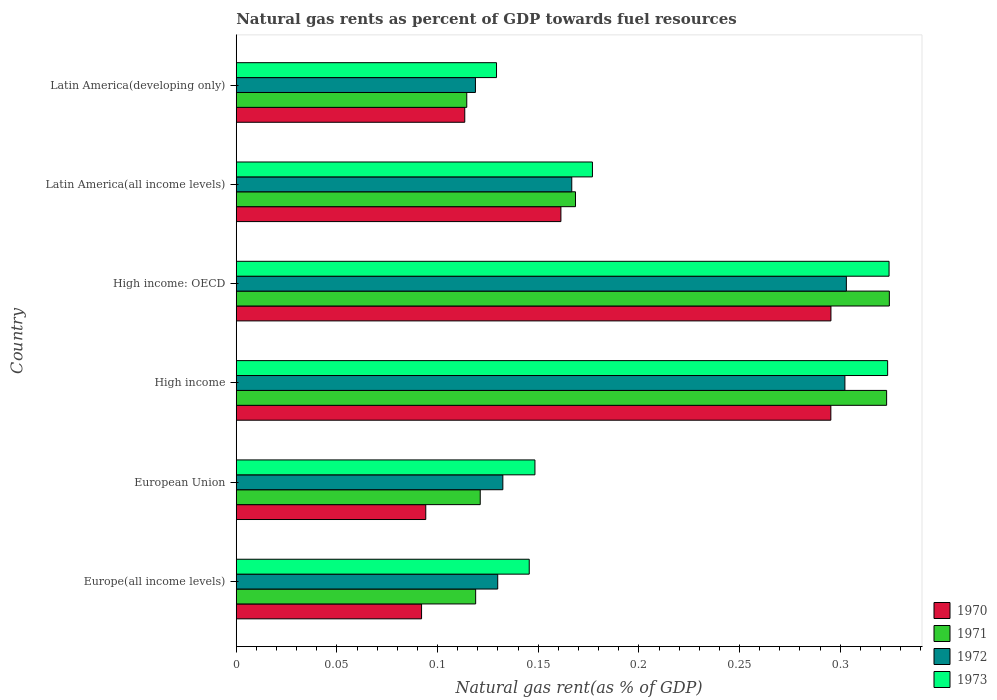How many different coloured bars are there?
Make the answer very short. 4. How many bars are there on the 3rd tick from the top?
Ensure brevity in your answer.  4. What is the label of the 1st group of bars from the top?
Your answer should be compact. Latin America(developing only). What is the natural gas rent in 1972 in Latin America(developing only)?
Keep it short and to the point. 0.12. Across all countries, what is the maximum natural gas rent in 1972?
Give a very brief answer. 0.3. Across all countries, what is the minimum natural gas rent in 1971?
Offer a very short reply. 0.11. In which country was the natural gas rent in 1971 maximum?
Keep it short and to the point. High income: OECD. In which country was the natural gas rent in 1972 minimum?
Provide a short and direct response. Latin America(developing only). What is the total natural gas rent in 1973 in the graph?
Give a very brief answer. 1.25. What is the difference between the natural gas rent in 1972 in Europe(all income levels) and that in High income?
Your response must be concise. -0.17. What is the difference between the natural gas rent in 1971 in Latin America(all income levels) and the natural gas rent in 1972 in European Union?
Offer a terse response. 0.04. What is the average natural gas rent in 1971 per country?
Your response must be concise. 0.2. What is the difference between the natural gas rent in 1972 and natural gas rent in 1971 in European Union?
Ensure brevity in your answer.  0.01. What is the ratio of the natural gas rent in 1973 in High income: OECD to that in Latin America(all income levels)?
Offer a terse response. 1.83. What is the difference between the highest and the second highest natural gas rent in 1972?
Give a very brief answer. 0. What is the difference between the highest and the lowest natural gas rent in 1973?
Offer a very short reply. 0.19. In how many countries, is the natural gas rent in 1970 greater than the average natural gas rent in 1970 taken over all countries?
Provide a succinct answer. 2. Is the sum of the natural gas rent in 1973 in European Union and High income greater than the maximum natural gas rent in 1972 across all countries?
Make the answer very short. Yes. Is it the case that in every country, the sum of the natural gas rent in 1971 and natural gas rent in 1973 is greater than the sum of natural gas rent in 1972 and natural gas rent in 1970?
Give a very brief answer. No. What does the 3rd bar from the bottom in High income: OECD represents?
Your answer should be compact. 1972. Are all the bars in the graph horizontal?
Ensure brevity in your answer.  Yes. How many countries are there in the graph?
Offer a terse response. 6. Are the values on the major ticks of X-axis written in scientific E-notation?
Give a very brief answer. No. Does the graph contain grids?
Your answer should be very brief. No. How many legend labels are there?
Your response must be concise. 4. How are the legend labels stacked?
Your answer should be compact. Vertical. What is the title of the graph?
Your answer should be very brief. Natural gas rents as percent of GDP towards fuel resources. Does "2005" appear as one of the legend labels in the graph?
Make the answer very short. No. What is the label or title of the X-axis?
Keep it short and to the point. Natural gas rent(as % of GDP). What is the Natural gas rent(as % of GDP) of 1970 in Europe(all income levels)?
Your answer should be very brief. 0.09. What is the Natural gas rent(as % of GDP) of 1971 in Europe(all income levels)?
Your response must be concise. 0.12. What is the Natural gas rent(as % of GDP) of 1972 in Europe(all income levels)?
Provide a succinct answer. 0.13. What is the Natural gas rent(as % of GDP) of 1973 in Europe(all income levels)?
Offer a terse response. 0.15. What is the Natural gas rent(as % of GDP) in 1970 in European Union?
Offer a terse response. 0.09. What is the Natural gas rent(as % of GDP) of 1971 in European Union?
Your answer should be very brief. 0.12. What is the Natural gas rent(as % of GDP) of 1972 in European Union?
Offer a terse response. 0.13. What is the Natural gas rent(as % of GDP) of 1973 in European Union?
Keep it short and to the point. 0.15. What is the Natural gas rent(as % of GDP) of 1970 in High income?
Your response must be concise. 0.3. What is the Natural gas rent(as % of GDP) of 1971 in High income?
Provide a short and direct response. 0.32. What is the Natural gas rent(as % of GDP) of 1972 in High income?
Ensure brevity in your answer.  0.3. What is the Natural gas rent(as % of GDP) in 1973 in High income?
Your answer should be compact. 0.32. What is the Natural gas rent(as % of GDP) in 1970 in High income: OECD?
Provide a succinct answer. 0.3. What is the Natural gas rent(as % of GDP) of 1971 in High income: OECD?
Your answer should be very brief. 0.32. What is the Natural gas rent(as % of GDP) in 1972 in High income: OECD?
Provide a succinct answer. 0.3. What is the Natural gas rent(as % of GDP) of 1973 in High income: OECD?
Give a very brief answer. 0.32. What is the Natural gas rent(as % of GDP) of 1970 in Latin America(all income levels)?
Provide a short and direct response. 0.16. What is the Natural gas rent(as % of GDP) in 1971 in Latin America(all income levels)?
Give a very brief answer. 0.17. What is the Natural gas rent(as % of GDP) of 1972 in Latin America(all income levels)?
Your answer should be compact. 0.17. What is the Natural gas rent(as % of GDP) of 1973 in Latin America(all income levels)?
Keep it short and to the point. 0.18. What is the Natural gas rent(as % of GDP) of 1970 in Latin America(developing only)?
Your answer should be compact. 0.11. What is the Natural gas rent(as % of GDP) of 1971 in Latin America(developing only)?
Offer a very short reply. 0.11. What is the Natural gas rent(as % of GDP) of 1972 in Latin America(developing only)?
Your answer should be very brief. 0.12. What is the Natural gas rent(as % of GDP) in 1973 in Latin America(developing only)?
Offer a terse response. 0.13. Across all countries, what is the maximum Natural gas rent(as % of GDP) of 1970?
Your answer should be compact. 0.3. Across all countries, what is the maximum Natural gas rent(as % of GDP) of 1971?
Provide a short and direct response. 0.32. Across all countries, what is the maximum Natural gas rent(as % of GDP) in 1972?
Give a very brief answer. 0.3. Across all countries, what is the maximum Natural gas rent(as % of GDP) of 1973?
Ensure brevity in your answer.  0.32. Across all countries, what is the minimum Natural gas rent(as % of GDP) in 1970?
Give a very brief answer. 0.09. Across all countries, what is the minimum Natural gas rent(as % of GDP) in 1971?
Keep it short and to the point. 0.11. Across all countries, what is the minimum Natural gas rent(as % of GDP) of 1972?
Your answer should be compact. 0.12. Across all countries, what is the minimum Natural gas rent(as % of GDP) of 1973?
Offer a terse response. 0.13. What is the total Natural gas rent(as % of GDP) of 1970 in the graph?
Make the answer very short. 1.05. What is the total Natural gas rent(as % of GDP) of 1971 in the graph?
Provide a short and direct response. 1.17. What is the total Natural gas rent(as % of GDP) of 1972 in the graph?
Provide a succinct answer. 1.15. What is the total Natural gas rent(as % of GDP) of 1973 in the graph?
Your response must be concise. 1.25. What is the difference between the Natural gas rent(as % of GDP) in 1970 in Europe(all income levels) and that in European Union?
Ensure brevity in your answer.  -0. What is the difference between the Natural gas rent(as % of GDP) in 1971 in Europe(all income levels) and that in European Union?
Ensure brevity in your answer.  -0. What is the difference between the Natural gas rent(as % of GDP) of 1972 in Europe(all income levels) and that in European Union?
Make the answer very short. -0. What is the difference between the Natural gas rent(as % of GDP) of 1973 in Europe(all income levels) and that in European Union?
Your answer should be compact. -0. What is the difference between the Natural gas rent(as % of GDP) in 1970 in Europe(all income levels) and that in High income?
Keep it short and to the point. -0.2. What is the difference between the Natural gas rent(as % of GDP) in 1971 in Europe(all income levels) and that in High income?
Offer a terse response. -0.2. What is the difference between the Natural gas rent(as % of GDP) of 1972 in Europe(all income levels) and that in High income?
Make the answer very short. -0.17. What is the difference between the Natural gas rent(as % of GDP) of 1973 in Europe(all income levels) and that in High income?
Make the answer very short. -0.18. What is the difference between the Natural gas rent(as % of GDP) of 1970 in Europe(all income levels) and that in High income: OECD?
Your response must be concise. -0.2. What is the difference between the Natural gas rent(as % of GDP) of 1971 in Europe(all income levels) and that in High income: OECD?
Your response must be concise. -0.21. What is the difference between the Natural gas rent(as % of GDP) of 1972 in Europe(all income levels) and that in High income: OECD?
Provide a succinct answer. -0.17. What is the difference between the Natural gas rent(as % of GDP) of 1973 in Europe(all income levels) and that in High income: OECD?
Give a very brief answer. -0.18. What is the difference between the Natural gas rent(as % of GDP) in 1970 in Europe(all income levels) and that in Latin America(all income levels)?
Offer a very short reply. -0.07. What is the difference between the Natural gas rent(as % of GDP) of 1971 in Europe(all income levels) and that in Latin America(all income levels)?
Provide a succinct answer. -0.05. What is the difference between the Natural gas rent(as % of GDP) of 1972 in Europe(all income levels) and that in Latin America(all income levels)?
Your response must be concise. -0.04. What is the difference between the Natural gas rent(as % of GDP) of 1973 in Europe(all income levels) and that in Latin America(all income levels)?
Your answer should be compact. -0.03. What is the difference between the Natural gas rent(as % of GDP) of 1970 in Europe(all income levels) and that in Latin America(developing only)?
Offer a terse response. -0.02. What is the difference between the Natural gas rent(as % of GDP) of 1971 in Europe(all income levels) and that in Latin America(developing only)?
Give a very brief answer. 0. What is the difference between the Natural gas rent(as % of GDP) of 1972 in Europe(all income levels) and that in Latin America(developing only)?
Provide a short and direct response. 0.01. What is the difference between the Natural gas rent(as % of GDP) of 1973 in Europe(all income levels) and that in Latin America(developing only)?
Provide a succinct answer. 0.02. What is the difference between the Natural gas rent(as % of GDP) in 1970 in European Union and that in High income?
Make the answer very short. -0.2. What is the difference between the Natural gas rent(as % of GDP) of 1971 in European Union and that in High income?
Make the answer very short. -0.2. What is the difference between the Natural gas rent(as % of GDP) of 1972 in European Union and that in High income?
Provide a succinct answer. -0.17. What is the difference between the Natural gas rent(as % of GDP) of 1973 in European Union and that in High income?
Your answer should be compact. -0.18. What is the difference between the Natural gas rent(as % of GDP) in 1970 in European Union and that in High income: OECD?
Make the answer very short. -0.2. What is the difference between the Natural gas rent(as % of GDP) of 1971 in European Union and that in High income: OECD?
Provide a short and direct response. -0.2. What is the difference between the Natural gas rent(as % of GDP) of 1972 in European Union and that in High income: OECD?
Provide a short and direct response. -0.17. What is the difference between the Natural gas rent(as % of GDP) in 1973 in European Union and that in High income: OECD?
Make the answer very short. -0.18. What is the difference between the Natural gas rent(as % of GDP) in 1970 in European Union and that in Latin America(all income levels)?
Offer a very short reply. -0.07. What is the difference between the Natural gas rent(as % of GDP) of 1971 in European Union and that in Latin America(all income levels)?
Give a very brief answer. -0.05. What is the difference between the Natural gas rent(as % of GDP) in 1972 in European Union and that in Latin America(all income levels)?
Offer a terse response. -0.03. What is the difference between the Natural gas rent(as % of GDP) of 1973 in European Union and that in Latin America(all income levels)?
Keep it short and to the point. -0.03. What is the difference between the Natural gas rent(as % of GDP) in 1970 in European Union and that in Latin America(developing only)?
Give a very brief answer. -0.02. What is the difference between the Natural gas rent(as % of GDP) in 1971 in European Union and that in Latin America(developing only)?
Keep it short and to the point. 0.01. What is the difference between the Natural gas rent(as % of GDP) in 1972 in European Union and that in Latin America(developing only)?
Your answer should be compact. 0.01. What is the difference between the Natural gas rent(as % of GDP) in 1973 in European Union and that in Latin America(developing only)?
Your answer should be compact. 0.02. What is the difference between the Natural gas rent(as % of GDP) in 1970 in High income and that in High income: OECD?
Your response must be concise. -0. What is the difference between the Natural gas rent(as % of GDP) in 1971 in High income and that in High income: OECD?
Provide a short and direct response. -0. What is the difference between the Natural gas rent(as % of GDP) of 1972 in High income and that in High income: OECD?
Make the answer very short. -0. What is the difference between the Natural gas rent(as % of GDP) in 1973 in High income and that in High income: OECD?
Give a very brief answer. -0. What is the difference between the Natural gas rent(as % of GDP) of 1970 in High income and that in Latin America(all income levels)?
Provide a succinct answer. 0.13. What is the difference between the Natural gas rent(as % of GDP) in 1971 in High income and that in Latin America(all income levels)?
Provide a succinct answer. 0.15. What is the difference between the Natural gas rent(as % of GDP) in 1972 in High income and that in Latin America(all income levels)?
Provide a succinct answer. 0.14. What is the difference between the Natural gas rent(as % of GDP) of 1973 in High income and that in Latin America(all income levels)?
Give a very brief answer. 0.15. What is the difference between the Natural gas rent(as % of GDP) of 1970 in High income and that in Latin America(developing only)?
Your answer should be very brief. 0.18. What is the difference between the Natural gas rent(as % of GDP) of 1971 in High income and that in Latin America(developing only)?
Keep it short and to the point. 0.21. What is the difference between the Natural gas rent(as % of GDP) of 1972 in High income and that in Latin America(developing only)?
Ensure brevity in your answer.  0.18. What is the difference between the Natural gas rent(as % of GDP) of 1973 in High income and that in Latin America(developing only)?
Make the answer very short. 0.19. What is the difference between the Natural gas rent(as % of GDP) in 1970 in High income: OECD and that in Latin America(all income levels)?
Make the answer very short. 0.13. What is the difference between the Natural gas rent(as % of GDP) of 1971 in High income: OECD and that in Latin America(all income levels)?
Offer a very short reply. 0.16. What is the difference between the Natural gas rent(as % of GDP) of 1972 in High income: OECD and that in Latin America(all income levels)?
Provide a short and direct response. 0.14. What is the difference between the Natural gas rent(as % of GDP) of 1973 in High income: OECD and that in Latin America(all income levels)?
Ensure brevity in your answer.  0.15. What is the difference between the Natural gas rent(as % of GDP) of 1970 in High income: OECD and that in Latin America(developing only)?
Your answer should be compact. 0.18. What is the difference between the Natural gas rent(as % of GDP) in 1971 in High income: OECD and that in Latin America(developing only)?
Your answer should be very brief. 0.21. What is the difference between the Natural gas rent(as % of GDP) in 1972 in High income: OECD and that in Latin America(developing only)?
Make the answer very short. 0.18. What is the difference between the Natural gas rent(as % of GDP) of 1973 in High income: OECD and that in Latin America(developing only)?
Your answer should be compact. 0.2. What is the difference between the Natural gas rent(as % of GDP) in 1970 in Latin America(all income levels) and that in Latin America(developing only)?
Your response must be concise. 0.05. What is the difference between the Natural gas rent(as % of GDP) in 1971 in Latin America(all income levels) and that in Latin America(developing only)?
Keep it short and to the point. 0.05. What is the difference between the Natural gas rent(as % of GDP) of 1972 in Latin America(all income levels) and that in Latin America(developing only)?
Keep it short and to the point. 0.05. What is the difference between the Natural gas rent(as % of GDP) of 1973 in Latin America(all income levels) and that in Latin America(developing only)?
Give a very brief answer. 0.05. What is the difference between the Natural gas rent(as % of GDP) in 1970 in Europe(all income levels) and the Natural gas rent(as % of GDP) in 1971 in European Union?
Your answer should be compact. -0.03. What is the difference between the Natural gas rent(as % of GDP) of 1970 in Europe(all income levels) and the Natural gas rent(as % of GDP) of 1972 in European Union?
Make the answer very short. -0.04. What is the difference between the Natural gas rent(as % of GDP) in 1970 in Europe(all income levels) and the Natural gas rent(as % of GDP) in 1973 in European Union?
Offer a very short reply. -0.06. What is the difference between the Natural gas rent(as % of GDP) of 1971 in Europe(all income levels) and the Natural gas rent(as % of GDP) of 1972 in European Union?
Give a very brief answer. -0.01. What is the difference between the Natural gas rent(as % of GDP) in 1971 in Europe(all income levels) and the Natural gas rent(as % of GDP) in 1973 in European Union?
Your response must be concise. -0.03. What is the difference between the Natural gas rent(as % of GDP) in 1972 in Europe(all income levels) and the Natural gas rent(as % of GDP) in 1973 in European Union?
Offer a terse response. -0.02. What is the difference between the Natural gas rent(as % of GDP) of 1970 in Europe(all income levels) and the Natural gas rent(as % of GDP) of 1971 in High income?
Provide a short and direct response. -0.23. What is the difference between the Natural gas rent(as % of GDP) in 1970 in Europe(all income levels) and the Natural gas rent(as % of GDP) in 1972 in High income?
Offer a terse response. -0.21. What is the difference between the Natural gas rent(as % of GDP) of 1970 in Europe(all income levels) and the Natural gas rent(as % of GDP) of 1973 in High income?
Your answer should be very brief. -0.23. What is the difference between the Natural gas rent(as % of GDP) in 1971 in Europe(all income levels) and the Natural gas rent(as % of GDP) in 1972 in High income?
Provide a short and direct response. -0.18. What is the difference between the Natural gas rent(as % of GDP) in 1971 in Europe(all income levels) and the Natural gas rent(as % of GDP) in 1973 in High income?
Provide a short and direct response. -0.2. What is the difference between the Natural gas rent(as % of GDP) in 1972 in Europe(all income levels) and the Natural gas rent(as % of GDP) in 1973 in High income?
Offer a terse response. -0.19. What is the difference between the Natural gas rent(as % of GDP) of 1970 in Europe(all income levels) and the Natural gas rent(as % of GDP) of 1971 in High income: OECD?
Ensure brevity in your answer.  -0.23. What is the difference between the Natural gas rent(as % of GDP) in 1970 in Europe(all income levels) and the Natural gas rent(as % of GDP) in 1972 in High income: OECD?
Offer a very short reply. -0.21. What is the difference between the Natural gas rent(as % of GDP) in 1970 in Europe(all income levels) and the Natural gas rent(as % of GDP) in 1973 in High income: OECD?
Make the answer very short. -0.23. What is the difference between the Natural gas rent(as % of GDP) of 1971 in Europe(all income levels) and the Natural gas rent(as % of GDP) of 1972 in High income: OECD?
Give a very brief answer. -0.18. What is the difference between the Natural gas rent(as % of GDP) in 1971 in Europe(all income levels) and the Natural gas rent(as % of GDP) in 1973 in High income: OECD?
Provide a short and direct response. -0.21. What is the difference between the Natural gas rent(as % of GDP) in 1972 in Europe(all income levels) and the Natural gas rent(as % of GDP) in 1973 in High income: OECD?
Provide a succinct answer. -0.19. What is the difference between the Natural gas rent(as % of GDP) in 1970 in Europe(all income levels) and the Natural gas rent(as % of GDP) in 1971 in Latin America(all income levels)?
Provide a short and direct response. -0.08. What is the difference between the Natural gas rent(as % of GDP) in 1970 in Europe(all income levels) and the Natural gas rent(as % of GDP) in 1972 in Latin America(all income levels)?
Keep it short and to the point. -0.07. What is the difference between the Natural gas rent(as % of GDP) of 1970 in Europe(all income levels) and the Natural gas rent(as % of GDP) of 1973 in Latin America(all income levels)?
Offer a very short reply. -0.08. What is the difference between the Natural gas rent(as % of GDP) of 1971 in Europe(all income levels) and the Natural gas rent(as % of GDP) of 1972 in Latin America(all income levels)?
Keep it short and to the point. -0.05. What is the difference between the Natural gas rent(as % of GDP) of 1971 in Europe(all income levels) and the Natural gas rent(as % of GDP) of 1973 in Latin America(all income levels)?
Offer a very short reply. -0.06. What is the difference between the Natural gas rent(as % of GDP) of 1972 in Europe(all income levels) and the Natural gas rent(as % of GDP) of 1973 in Latin America(all income levels)?
Give a very brief answer. -0.05. What is the difference between the Natural gas rent(as % of GDP) in 1970 in Europe(all income levels) and the Natural gas rent(as % of GDP) in 1971 in Latin America(developing only)?
Your answer should be very brief. -0.02. What is the difference between the Natural gas rent(as % of GDP) of 1970 in Europe(all income levels) and the Natural gas rent(as % of GDP) of 1972 in Latin America(developing only)?
Give a very brief answer. -0.03. What is the difference between the Natural gas rent(as % of GDP) of 1970 in Europe(all income levels) and the Natural gas rent(as % of GDP) of 1973 in Latin America(developing only)?
Your response must be concise. -0.04. What is the difference between the Natural gas rent(as % of GDP) of 1971 in Europe(all income levels) and the Natural gas rent(as % of GDP) of 1973 in Latin America(developing only)?
Offer a very short reply. -0.01. What is the difference between the Natural gas rent(as % of GDP) of 1972 in Europe(all income levels) and the Natural gas rent(as % of GDP) of 1973 in Latin America(developing only)?
Give a very brief answer. 0. What is the difference between the Natural gas rent(as % of GDP) in 1970 in European Union and the Natural gas rent(as % of GDP) in 1971 in High income?
Give a very brief answer. -0.23. What is the difference between the Natural gas rent(as % of GDP) of 1970 in European Union and the Natural gas rent(as % of GDP) of 1972 in High income?
Your answer should be very brief. -0.21. What is the difference between the Natural gas rent(as % of GDP) of 1970 in European Union and the Natural gas rent(as % of GDP) of 1973 in High income?
Make the answer very short. -0.23. What is the difference between the Natural gas rent(as % of GDP) in 1971 in European Union and the Natural gas rent(as % of GDP) in 1972 in High income?
Provide a succinct answer. -0.18. What is the difference between the Natural gas rent(as % of GDP) of 1971 in European Union and the Natural gas rent(as % of GDP) of 1973 in High income?
Your response must be concise. -0.2. What is the difference between the Natural gas rent(as % of GDP) in 1972 in European Union and the Natural gas rent(as % of GDP) in 1973 in High income?
Ensure brevity in your answer.  -0.19. What is the difference between the Natural gas rent(as % of GDP) of 1970 in European Union and the Natural gas rent(as % of GDP) of 1971 in High income: OECD?
Your answer should be very brief. -0.23. What is the difference between the Natural gas rent(as % of GDP) in 1970 in European Union and the Natural gas rent(as % of GDP) in 1972 in High income: OECD?
Ensure brevity in your answer.  -0.21. What is the difference between the Natural gas rent(as % of GDP) of 1970 in European Union and the Natural gas rent(as % of GDP) of 1973 in High income: OECD?
Provide a short and direct response. -0.23. What is the difference between the Natural gas rent(as % of GDP) of 1971 in European Union and the Natural gas rent(as % of GDP) of 1972 in High income: OECD?
Provide a short and direct response. -0.18. What is the difference between the Natural gas rent(as % of GDP) of 1971 in European Union and the Natural gas rent(as % of GDP) of 1973 in High income: OECD?
Provide a short and direct response. -0.2. What is the difference between the Natural gas rent(as % of GDP) in 1972 in European Union and the Natural gas rent(as % of GDP) in 1973 in High income: OECD?
Give a very brief answer. -0.19. What is the difference between the Natural gas rent(as % of GDP) in 1970 in European Union and the Natural gas rent(as % of GDP) in 1971 in Latin America(all income levels)?
Offer a very short reply. -0.07. What is the difference between the Natural gas rent(as % of GDP) of 1970 in European Union and the Natural gas rent(as % of GDP) of 1972 in Latin America(all income levels)?
Offer a terse response. -0.07. What is the difference between the Natural gas rent(as % of GDP) in 1970 in European Union and the Natural gas rent(as % of GDP) in 1973 in Latin America(all income levels)?
Your answer should be compact. -0.08. What is the difference between the Natural gas rent(as % of GDP) of 1971 in European Union and the Natural gas rent(as % of GDP) of 1972 in Latin America(all income levels)?
Your answer should be compact. -0.05. What is the difference between the Natural gas rent(as % of GDP) of 1971 in European Union and the Natural gas rent(as % of GDP) of 1973 in Latin America(all income levels)?
Your answer should be very brief. -0.06. What is the difference between the Natural gas rent(as % of GDP) in 1972 in European Union and the Natural gas rent(as % of GDP) in 1973 in Latin America(all income levels)?
Give a very brief answer. -0.04. What is the difference between the Natural gas rent(as % of GDP) in 1970 in European Union and the Natural gas rent(as % of GDP) in 1971 in Latin America(developing only)?
Offer a terse response. -0.02. What is the difference between the Natural gas rent(as % of GDP) of 1970 in European Union and the Natural gas rent(as % of GDP) of 1972 in Latin America(developing only)?
Your answer should be compact. -0.02. What is the difference between the Natural gas rent(as % of GDP) in 1970 in European Union and the Natural gas rent(as % of GDP) in 1973 in Latin America(developing only)?
Keep it short and to the point. -0.04. What is the difference between the Natural gas rent(as % of GDP) in 1971 in European Union and the Natural gas rent(as % of GDP) in 1972 in Latin America(developing only)?
Provide a short and direct response. 0. What is the difference between the Natural gas rent(as % of GDP) in 1971 in European Union and the Natural gas rent(as % of GDP) in 1973 in Latin America(developing only)?
Make the answer very short. -0.01. What is the difference between the Natural gas rent(as % of GDP) in 1972 in European Union and the Natural gas rent(as % of GDP) in 1973 in Latin America(developing only)?
Your response must be concise. 0. What is the difference between the Natural gas rent(as % of GDP) of 1970 in High income and the Natural gas rent(as % of GDP) of 1971 in High income: OECD?
Keep it short and to the point. -0.03. What is the difference between the Natural gas rent(as % of GDP) of 1970 in High income and the Natural gas rent(as % of GDP) of 1972 in High income: OECD?
Ensure brevity in your answer.  -0.01. What is the difference between the Natural gas rent(as % of GDP) of 1970 in High income and the Natural gas rent(as % of GDP) of 1973 in High income: OECD?
Offer a terse response. -0.03. What is the difference between the Natural gas rent(as % of GDP) of 1971 in High income and the Natural gas rent(as % of GDP) of 1973 in High income: OECD?
Your answer should be compact. -0. What is the difference between the Natural gas rent(as % of GDP) in 1972 in High income and the Natural gas rent(as % of GDP) in 1973 in High income: OECD?
Your answer should be very brief. -0.02. What is the difference between the Natural gas rent(as % of GDP) of 1970 in High income and the Natural gas rent(as % of GDP) of 1971 in Latin America(all income levels)?
Offer a very short reply. 0.13. What is the difference between the Natural gas rent(as % of GDP) in 1970 in High income and the Natural gas rent(as % of GDP) in 1972 in Latin America(all income levels)?
Provide a short and direct response. 0.13. What is the difference between the Natural gas rent(as % of GDP) of 1970 in High income and the Natural gas rent(as % of GDP) of 1973 in Latin America(all income levels)?
Your answer should be very brief. 0.12. What is the difference between the Natural gas rent(as % of GDP) in 1971 in High income and the Natural gas rent(as % of GDP) in 1972 in Latin America(all income levels)?
Your answer should be very brief. 0.16. What is the difference between the Natural gas rent(as % of GDP) of 1971 in High income and the Natural gas rent(as % of GDP) of 1973 in Latin America(all income levels)?
Keep it short and to the point. 0.15. What is the difference between the Natural gas rent(as % of GDP) in 1972 in High income and the Natural gas rent(as % of GDP) in 1973 in Latin America(all income levels)?
Provide a short and direct response. 0.13. What is the difference between the Natural gas rent(as % of GDP) in 1970 in High income and the Natural gas rent(as % of GDP) in 1971 in Latin America(developing only)?
Give a very brief answer. 0.18. What is the difference between the Natural gas rent(as % of GDP) of 1970 in High income and the Natural gas rent(as % of GDP) of 1972 in Latin America(developing only)?
Your answer should be compact. 0.18. What is the difference between the Natural gas rent(as % of GDP) of 1970 in High income and the Natural gas rent(as % of GDP) of 1973 in Latin America(developing only)?
Your answer should be very brief. 0.17. What is the difference between the Natural gas rent(as % of GDP) in 1971 in High income and the Natural gas rent(as % of GDP) in 1972 in Latin America(developing only)?
Keep it short and to the point. 0.2. What is the difference between the Natural gas rent(as % of GDP) of 1971 in High income and the Natural gas rent(as % of GDP) of 1973 in Latin America(developing only)?
Offer a terse response. 0.19. What is the difference between the Natural gas rent(as % of GDP) of 1972 in High income and the Natural gas rent(as % of GDP) of 1973 in Latin America(developing only)?
Offer a terse response. 0.17. What is the difference between the Natural gas rent(as % of GDP) in 1970 in High income: OECD and the Natural gas rent(as % of GDP) in 1971 in Latin America(all income levels)?
Your answer should be compact. 0.13. What is the difference between the Natural gas rent(as % of GDP) of 1970 in High income: OECD and the Natural gas rent(as % of GDP) of 1972 in Latin America(all income levels)?
Provide a short and direct response. 0.13. What is the difference between the Natural gas rent(as % of GDP) of 1970 in High income: OECD and the Natural gas rent(as % of GDP) of 1973 in Latin America(all income levels)?
Offer a very short reply. 0.12. What is the difference between the Natural gas rent(as % of GDP) of 1971 in High income: OECD and the Natural gas rent(as % of GDP) of 1972 in Latin America(all income levels)?
Your answer should be very brief. 0.16. What is the difference between the Natural gas rent(as % of GDP) in 1971 in High income: OECD and the Natural gas rent(as % of GDP) in 1973 in Latin America(all income levels)?
Provide a succinct answer. 0.15. What is the difference between the Natural gas rent(as % of GDP) of 1972 in High income: OECD and the Natural gas rent(as % of GDP) of 1973 in Latin America(all income levels)?
Provide a succinct answer. 0.13. What is the difference between the Natural gas rent(as % of GDP) of 1970 in High income: OECD and the Natural gas rent(as % of GDP) of 1971 in Latin America(developing only)?
Keep it short and to the point. 0.18. What is the difference between the Natural gas rent(as % of GDP) in 1970 in High income: OECD and the Natural gas rent(as % of GDP) in 1972 in Latin America(developing only)?
Provide a short and direct response. 0.18. What is the difference between the Natural gas rent(as % of GDP) in 1970 in High income: OECD and the Natural gas rent(as % of GDP) in 1973 in Latin America(developing only)?
Provide a succinct answer. 0.17. What is the difference between the Natural gas rent(as % of GDP) of 1971 in High income: OECD and the Natural gas rent(as % of GDP) of 1972 in Latin America(developing only)?
Give a very brief answer. 0.21. What is the difference between the Natural gas rent(as % of GDP) of 1971 in High income: OECD and the Natural gas rent(as % of GDP) of 1973 in Latin America(developing only)?
Make the answer very short. 0.2. What is the difference between the Natural gas rent(as % of GDP) of 1972 in High income: OECD and the Natural gas rent(as % of GDP) of 1973 in Latin America(developing only)?
Your response must be concise. 0.17. What is the difference between the Natural gas rent(as % of GDP) of 1970 in Latin America(all income levels) and the Natural gas rent(as % of GDP) of 1971 in Latin America(developing only)?
Provide a short and direct response. 0.05. What is the difference between the Natural gas rent(as % of GDP) of 1970 in Latin America(all income levels) and the Natural gas rent(as % of GDP) of 1972 in Latin America(developing only)?
Offer a very short reply. 0.04. What is the difference between the Natural gas rent(as % of GDP) of 1970 in Latin America(all income levels) and the Natural gas rent(as % of GDP) of 1973 in Latin America(developing only)?
Offer a terse response. 0.03. What is the difference between the Natural gas rent(as % of GDP) of 1971 in Latin America(all income levels) and the Natural gas rent(as % of GDP) of 1972 in Latin America(developing only)?
Provide a succinct answer. 0.05. What is the difference between the Natural gas rent(as % of GDP) in 1971 in Latin America(all income levels) and the Natural gas rent(as % of GDP) in 1973 in Latin America(developing only)?
Ensure brevity in your answer.  0.04. What is the difference between the Natural gas rent(as % of GDP) of 1972 in Latin America(all income levels) and the Natural gas rent(as % of GDP) of 1973 in Latin America(developing only)?
Your answer should be very brief. 0.04. What is the average Natural gas rent(as % of GDP) of 1970 per country?
Ensure brevity in your answer.  0.18. What is the average Natural gas rent(as % of GDP) in 1971 per country?
Provide a short and direct response. 0.2. What is the average Natural gas rent(as % of GDP) in 1972 per country?
Your answer should be very brief. 0.19. What is the average Natural gas rent(as % of GDP) in 1973 per country?
Provide a succinct answer. 0.21. What is the difference between the Natural gas rent(as % of GDP) in 1970 and Natural gas rent(as % of GDP) in 1971 in Europe(all income levels)?
Your answer should be very brief. -0.03. What is the difference between the Natural gas rent(as % of GDP) of 1970 and Natural gas rent(as % of GDP) of 1972 in Europe(all income levels)?
Make the answer very short. -0.04. What is the difference between the Natural gas rent(as % of GDP) of 1970 and Natural gas rent(as % of GDP) of 1973 in Europe(all income levels)?
Provide a short and direct response. -0.05. What is the difference between the Natural gas rent(as % of GDP) in 1971 and Natural gas rent(as % of GDP) in 1972 in Europe(all income levels)?
Your answer should be very brief. -0.01. What is the difference between the Natural gas rent(as % of GDP) in 1971 and Natural gas rent(as % of GDP) in 1973 in Europe(all income levels)?
Offer a very short reply. -0.03. What is the difference between the Natural gas rent(as % of GDP) of 1972 and Natural gas rent(as % of GDP) of 1973 in Europe(all income levels)?
Your answer should be very brief. -0.02. What is the difference between the Natural gas rent(as % of GDP) of 1970 and Natural gas rent(as % of GDP) of 1971 in European Union?
Keep it short and to the point. -0.03. What is the difference between the Natural gas rent(as % of GDP) in 1970 and Natural gas rent(as % of GDP) in 1972 in European Union?
Provide a succinct answer. -0.04. What is the difference between the Natural gas rent(as % of GDP) of 1970 and Natural gas rent(as % of GDP) of 1973 in European Union?
Your answer should be compact. -0.05. What is the difference between the Natural gas rent(as % of GDP) of 1971 and Natural gas rent(as % of GDP) of 1972 in European Union?
Give a very brief answer. -0.01. What is the difference between the Natural gas rent(as % of GDP) of 1971 and Natural gas rent(as % of GDP) of 1973 in European Union?
Keep it short and to the point. -0.03. What is the difference between the Natural gas rent(as % of GDP) of 1972 and Natural gas rent(as % of GDP) of 1973 in European Union?
Offer a very short reply. -0.02. What is the difference between the Natural gas rent(as % of GDP) of 1970 and Natural gas rent(as % of GDP) of 1971 in High income?
Keep it short and to the point. -0.03. What is the difference between the Natural gas rent(as % of GDP) in 1970 and Natural gas rent(as % of GDP) in 1972 in High income?
Offer a terse response. -0.01. What is the difference between the Natural gas rent(as % of GDP) of 1970 and Natural gas rent(as % of GDP) of 1973 in High income?
Your answer should be very brief. -0.03. What is the difference between the Natural gas rent(as % of GDP) in 1971 and Natural gas rent(as % of GDP) in 1972 in High income?
Make the answer very short. 0.02. What is the difference between the Natural gas rent(as % of GDP) of 1971 and Natural gas rent(as % of GDP) of 1973 in High income?
Your answer should be very brief. -0. What is the difference between the Natural gas rent(as % of GDP) of 1972 and Natural gas rent(as % of GDP) of 1973 in High income?
Your answer should be very brief. -0.02. What is the difference between the Natural gas rent(as % of GDP) in 1970 and Natural gas rent(as % of GDP) in 1971 in High income: OECD?
Provide a succinct answer. -0.03. What is the difference between the Natural gas rent(as % of GDP) of 1970 and Natural gas rent(as % of GDP) of 1972 in High income: OECD?
Your answer should be very brief. -0.01. What is the difference between the Natural gas rent(as % of GDP) of 1970 and Natural gas rent(as % of GDP) of 1973 in High income: OECD?
Your answer should be very brief. -0.03. What is the difference between the Natural gas rent(as % of GDP) of 1971 and Natural gas rent(as % of GDP) of 1972 in High income: OECD?
Make the answer very short. 0.02. What is the difference between the Natural gas rent(as % of GDP) in 1971 and Natural gas rent(as % of GDP) in 1973 in High income: OECD?
Your answer should be very brief. 0. What is the difference between the Natural gas rent(as % of GDP) of 1972 and Natural gas rent(as % of GDP) of 1973 in High income: OECD?
Provide a short and direct response. -0.02. What is the difference between the Natural gas rent(as % of GDP) of 1970 and Natural gas rent(as % of GDP) of 1971 in Latin America(all income levels)?
Your answer should be compact. -0.01. What is the difference between the Natural gas rent(as % of GDP) in 1970 and Natural gas rent(as % of GDP) in 1972 in Latin America(all income levels)?
Offer a terse response. -0.01. What is the difference between the Natural gas rent(as % of GDP) in 1970 and Natural gas rent(as % of GDP) in 1973 in Latin America(all income levels)?
Keep it short and to the point. -0.02. What is the difference between the Natural gas rent(as % of GDP) of 1971 and Natural gas rent(as % of GDP) of 1972 in Latin America(all income levels)?
Your answer should be compact. 0. What is the difference between the Natural gas rent(as % of GDP) of 1971 and Natural gas rent(as % of GDP) of 1973 in Latin America(all income levels)?
Provide a succinct answer. -0.01. What is the difference between the Natural gas rent(as % of GDP) of 1972 and Natural gas rent(as % of GDP) of 1973 in Latin America(all income levels)?
Give a very brief answer. -0.01. What is the difference between the Natural gas rent(as % of GDP) in 1970 and Natural gas rent(as % of GDP) in 1971 in Latin America(developing only)?
Offer a very short reply. -0. What is the difference between the Natural gas rent(as % of GDP) in 1970 and Natural gas rent(as % of GDP) in 1972 in Latin America(developing only)?
Ensure brevity in your answer.  -0.01. What is the difference between the Natural gas rent(as % of GDP) of 1970 and Natural gas rent(as % of GDP) of 1973 in Latin America(developing only)?
Offer a terse response. -0.02. What is the difference between the Natural gas rent(as % of GDP) of 1971 and Natural gas rent(as % of GDP) of 1972 in Latin America(developing only)?
Offer a very short reply. -0. What is the difference between the Natural gas rent(as % of GDP) in 1971 and Natural gas rent(as % of GDP) in 1973 in Latin America(developing only)?
Ensure brevity in your answer.  -0.01. What is the difference between the Natural gas rent(as % of GDP) of 1972 and Natural gas rent(as % of GDP) of 1973 in Latin America(developing only)?
Offer a terse response. -0.01. What is the ratio of the Natural gas rent(as % of GDP) of 1970 in Europe(all income levels) to that in European Union?
Your answer should be compact. 0.98. What is the ratio of the Natural gas rent(as % of GDP) in 1971 in Europe(all income levels) to that in European Union?
Provide a succinct answer. 0.98. What is the ratio of the Natural gas rent(as % of GDP) in 1972 in Europe(all income levels) to that in European Union?
Ensure brevity in your answer.  0.98. What is the ratio of the Natural gas rent(as % of GDP) in 1973 in Europe(all income levels) to that in European Union?
Offer a very short reply. 0.98. What is the ratio of the Natural gas rent(as % of GDP) in 1970 in Europe(all income levels) to that in High income?
Your answer should be compact. 0.31. What is the ratio of the Natural gas rent(as % of GDP) of 1971 in Europe(all income levels) to that in High income?
Make the answer very short. 0.37. What is the ratio of the Natural gas rent(as % of GDP) in 1972 in Europe(all income levels) to that in High income?
Offer a very short reply. 0.43. What is the ratio of the Natural gas rent(as % of GDP) of 1973 in Europe(all income levels) to that in High income?
Give a very brief answer. 0.45. What is the ratio of the Natural gas rent(as % of GDP) in 1970 in Europe(all income levels) to that in High income: OECD?
Provide a succinct answer. 0.31. What is the ratio of the Natural gas rent(as % of GDP) in 1971 in Europe(all income levels) to that in High income: OECD?
Your answer should be very brief. 0.37. What is the ratio of the Natural gas rent(as % of GDP) of 1972 in Europe(all income levels) to that in High income: OECD?
Provide a succinct answer. 0.43. What is the ratio of the Natural gas rent(as % of GDP) in 1973 in Europe(all income levels) to that in High income: OECD?
Offer a very short reply. 0.45. What is the ratio of the Natural gas rent(as % of GDP) of 1970 in Europe(all income levels) to that in Latin America(all income levels)?
Ensure brevity in your answer.  0.57. What is the ratio of the Natural gas rent(as % of GDP) in 1971 in Europe(all income levels) to that in Latin America(all income levels)?
Your answer should be compact. 0.71. What is the ratio of the Natural gas rent(as % of GDP) in 1972 in Europe(all income levels) to that in Latin America(all income levels)?
Your answer should be very brief. 0.78. What is the ratio of the Natural gas rent(as % of GDP) in 1973 in Europe(all income levels) to that in Latin America(all income levels)?
Provide a short and direct response. 0.82. What is the ratio of the Natural gas rent(as % of GDP) of 1970 in Europe(all income levels) to that in Latin America(developing only)?
Offer a terse response. 0.81. What is the ratio of the Natural gas rent(as % of GDP) in 1971 in Europe(all income levels) to that in Latin America(developing only)?
Your answer should be very brief. 1.04. What is the ratio of the Natural gas rent(as % of GDP) in 1972 in Europe(all income levels) to that in Latin America(developing only)?
Offer a terse response. 1.09. What is the ratio of the Natural gas rent(as % of GDP) of 1973 in Europe(all income levels) to that in Latin America(developing only)?
Keep it short and to the point. 1.13. What is the ratio of the Natural gas rent(as % of GDP) in 1970 in European Union to that in High income?
Provide a succinct answer. 0.32. What is the ratio of the Natural gas rent(as % of GDP) in 1971 in European Union to that in High income?
Ensure brevity in your answer.  0.38. What is the ratio of the Natural gas rent(as % of GDP) in 1972 in European Union to that in High income?
Keep it short and to the point. 0.44. What is the ratio of the Natural gas rent(as % of GDP) in 1973 in European Union to that in High income?
Offer a terse response. 0.46. What is the ratio of the Natural gas rent(as % of GDP) in 1970 in European Union to that in High income: OECD?
Your response must be concise. 0.32. What is the ratio of the Natural gas rent(as % of GDP) in 1971 in European Union to that in High income: OECD?
Provide a short and direct response. 0.37. What is the ratio of the Natural gas rent(as % of GDP) in 1972 in European Union to that in High income: OECD?
Offer a terse response. 0.44. What is the ratio of the Natural gas rent(as % of GDP) in 1973 in European Union to that in High income: OECD?
Make the answer very short. 0.46. What is the ratio of the Natural gas rent(as % of GDP) in 1970 in European Union to that in Latin America(all income levels)?
Make the answer very short. 0.58. What is the ratio of the Natural gas rent(as % of GDP) of 1971 in European Union to that in Latin America(all income levels)?
Provide a succinct answer. 0.72. What is the ratio of the Natural gas rent(as % of GDP) of 1972 in European Union to that in Latin America(all income levels)?
Your answer should be very brief. 0.79. What is the ratio of the Natural gas rent(as % of GDP) in 1973 in European Union to that in Latin America(all income levels)?
Your answer should be compact. 0.84. What is the ratio of the Natural gas rent(as % of GDP) in 1970 in European Union to that in Latin America(developing only)?
Provide a short and direct response. 0.83. What is the ratio of the Natural gas rent(as % of GDP) of 1971 in European Union to that in Latin America(developing only)?
Make the answer very short. 1.06. What is the ratio of the Natural gas rent(as % of GDP) in 1972 in European Union to that in Latin America(developing only)?
Provide a short and direct response. 1.11. What is the ratio of the Natural gas rent(as % of GDP) in 1973 in European Union to that in Latin America(developing only)?
Make the answer very short. 1.15. What is the ratio of the Natural gas rent(as % of GDP) of 1970 in High income to that in High income: OECD?
Ensure brevity in your answer.  1. What is the ratio of the Natural gas rent(as % of GDP) of 1971 in High income to that in High income: OECD?
Give a very brief answer. 1. What is the ratio of the Natural gas rent(as % of GDP) of 1973 in High income to that in High income: OECD?
Offer a very short reply. 1. What is the ratio of the Natural gas rent(as % of GDP) of 1970 in High income to that in Latin America(all income levels)?
Offer a very short reply. 1.83. What is the ratio of the Natural gas rent(as % of GDP) of 1971 in High income to that in Latin America(all income levels)?
Provide a short and direct response. 1.92. What is the ratio of the Natural gas rent(as % of GDP) in 1972 in High income to that in Latin America(all income levels)?
Your response must be concise. 1.81. What is the ratio of the Natural gas rent(as % of GDP) in 1973 in High income to that in Latin America(all income levels)?
Provide a succinct answer. 1.83. What is the ratio of the Natural gas rent(as % of GDP) of 1970 in High income to that in Latin America(developing only)?
Keep it short and to the point. 2.6. What is the ratio of the Natural gas rent(as % of GDP) of 1971 in High income to that in Latin America(developing only)?
Your response must be concise. 2.82. What is the ratio of the Natural gas rent(as % of GDP) in 1972 in High income to that in Latin America(developing only)?
Your answer should be compact. 2.54. What is the ratio of the Natural gas rent(as % of GDP) of 1973 in High income to that in Latin America(developing only)?
Provide a short and direct response. 2.5. What is the ratio of the Natural gas rent(as % of GDP) of 1970 in High income: OECD to that in Latin America(all income levels)?
Make the answer very short. 1.83. What is the ratio of the Natural gas rent(as % of GDP) in 1971 in High income: OECD to that in Latin America(all income levels)?
Offer a terse response. 1.93. What is the ratio of the Natural gas rent(as % of GDP) in 1972 in High income: OECD to that in Latin America(all income levels)?
Make the answer very short. 1.82. What is the ratio of the Natural gas rent(as % of GDP) of 1973 in High income: OECD to that in Latin America(all income levels)?
Offer a terse response. 1.83. What is the ratio of the Natural gas rent(as % of GDP) of 1970 in High income: OECD to that in Latin America(developing only)?
Make the answer very short. 2.6. What is the ratio of the Natural gas rent(as % of GDP) in 1971 in High income: OECD to that in Latin America(developing only)?
Provide a succinct answer. 2.83. What is the ratio of the Natural gas rent(as % of GDP) of 1972 in High income: OECD to that in Latin America(developing only)?
Offer a very short reply. 2.55. What is the ratio of the Natural gas rent(as % of GDP) of 1973 in High income: OECD to that in Latin America(developing only)?
Ensure brevity in your answer.  2.51. What is the ratio of the Natural gas rent(as % of GDP) in 1970 in Latin America(all income levels) to that in Latin America(developing only)?
Offer a terse response. 1.42. What is the ratio of the Natural gas rent(as % of GDP) in 1971 in Latin America(all income levels) to that in Latin America(developing only)?
Offer a terse response. 1.47. What is the ratio of the Natural gas rent(as % of GDP) in 1972 in Latin America(all income levels) to that in Latin America(developing only)?
Your response must be concise. 1.4. What is the ratio of the Natural gas rent(as % of GDP) in 1973 in Latin America(all income levels) to that in Latin America(developing only)?
Your answer should be compact. 1.37. What is the difference between the highest and the second highest Natural gas rent(as % of GDP) in 1970?
Ensure brevity in your answer.  0. What is the difference between the highest and the second highest Natural gas rent(as % of GDP) of 1971?
Make the answer very short. 0. What is the difference between the highest and the second highest Natural gas rent(as % of GDP) of 1972?
Make the answer very short. 0. What is the difference between the highest and the second highest Natural gas rent(as % of GDP) of 1973?
Offer a very short reply. 0. What is the difference between the highest and the lowest Natural gas rent(as % of GDP) in 1970?
Offer a very short reply. 0.2. What is the difference between the highest and the lowest Natural gas rent(as % of GDP) in 1971?
Provide a short and direct response. 0.21. What is the difference between the highest and the lowest Natural gas rent(as % of GDP) of 1972?
Keep it short and to the point. 0.18. What is the difference between the highest and the lowest Natural gas rent(as % of GDP) in 1973?
Offer a terse response. 0.2. 